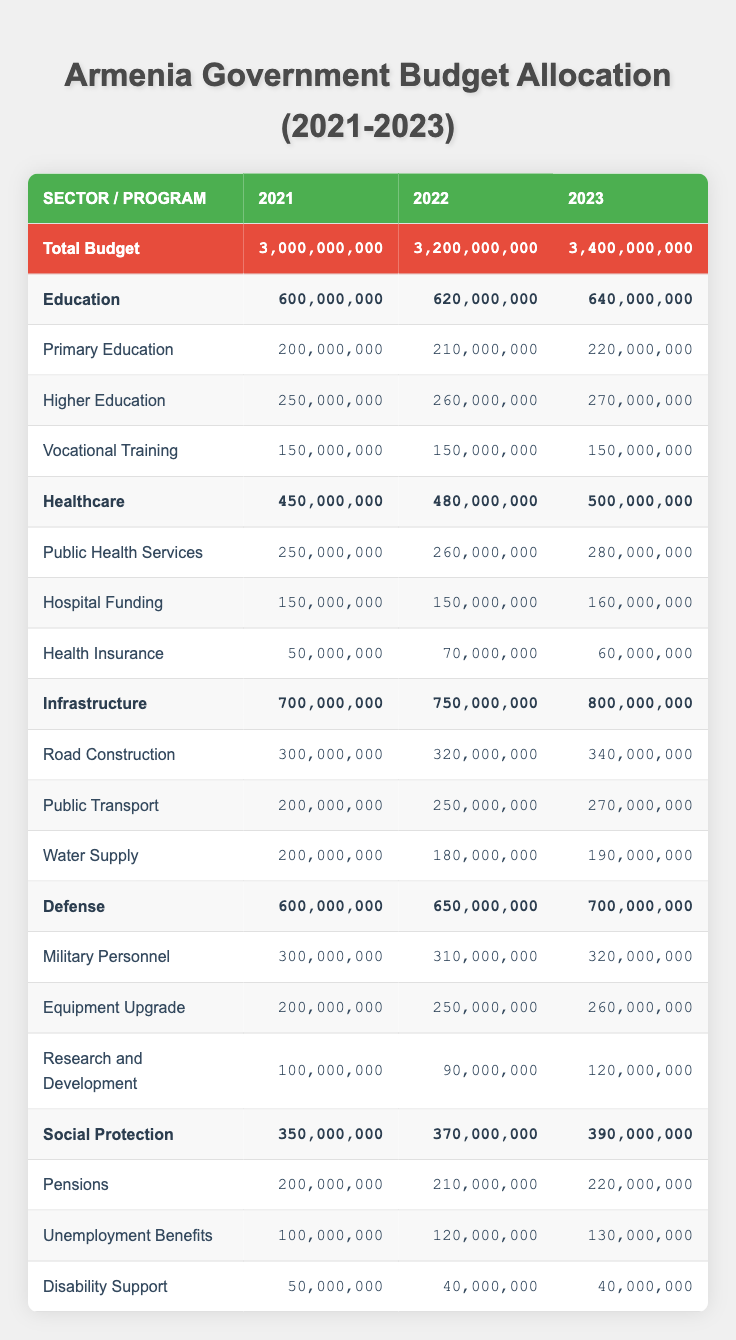What was the total budget for the year 2022? The table shows that the total budget for the year 2022 is listed directly under the "Total Budget" row for that year, which is 3,200,000,000.
Answer: 3,200,000,000 Which sector received the highest allocation in 2023? By examining the allocated amounts for each sector in 2023, we can see that Defense received 700,000,000, which is more than any other sector's allocation that year.
Answer: Defense What is the difference in allocated amount for Education between 2021 and 2023? The allocated amount for Education in 2021 is 600,000,000, while in 2023 it is 640,000,000. Therefore, the difference is 640,000,000 - 600,000,000 = 40,000,000.
Answer: 40,000,000 Is the allocated amount for Health Insurance in 2022 lower than in 2021? The allocated amounts show that Health Insurance in 2022 is 70,000,000, which is higher than the 50,000,000 allocated in 2021. So the statement is false.
Answer: No What is the total allocation for Social Protection across the three years? To find the total allocation for Social Protection, we sum the amounts for each year: 350,000,000 (2021) + 370,000,000 (2022) + 390,000,000 (2023) = 1,110,000,000.
Answer: 1,110,000,000 How much funding was allocated to Vocational Training in 2022 compared to 2021? The allocated amount for Vocational Training in 2021 is 150,000,000, and in 2022 it remains 150,000,000. Therefore, there is no change.
Answer: No change What percentage of the total budget in 2023 was allocated to Infrastructure? The total budget in 2023 is 3,400,000,000, and Infrastructure had an allocation of 800,000,000. To find the percentage: (800,000,000 / 3,400,000,000) * 100 = approximately 23.53%.
Answer: 23.53% Which program under Healthcare saw the most significant increase in funding from 2021 to 2023? By comparing the allocated amounts: Public Health Services: 250,000,000 to 280,000,000 (+30,000,000), Hospital Funding: 150,000,000 to 160,000,000 (+10,000,000), Health Insurance: 50,000,000 to 60,000,000 (+10,000,000). The largest increase was for Public Health Services.
Answer: Public Health Services 